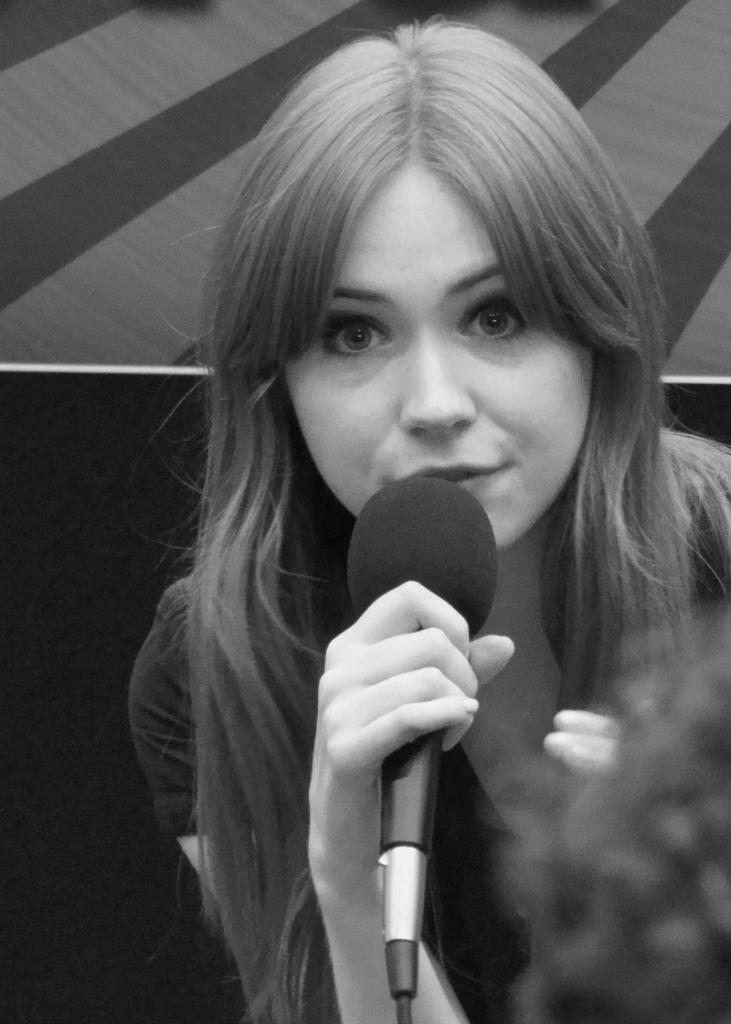Who is the main subject in the image? There is a woman in the image. What is the woman holding in the image? The woman is holding a microphone. What might the woman be doing with the microphone? The woman appears to be talking, which suggests she might be using the microphone to amplify her voice. What can be seen in the background of the image? There is a wall in the background of the image. What type of air can be seen in the image? There is no air visible in the image; it is a photograph of a woman holding a microphone. Can you tell me how many friends are present in the image? There are no friends present in the image; it features a woman holding a microphone. 